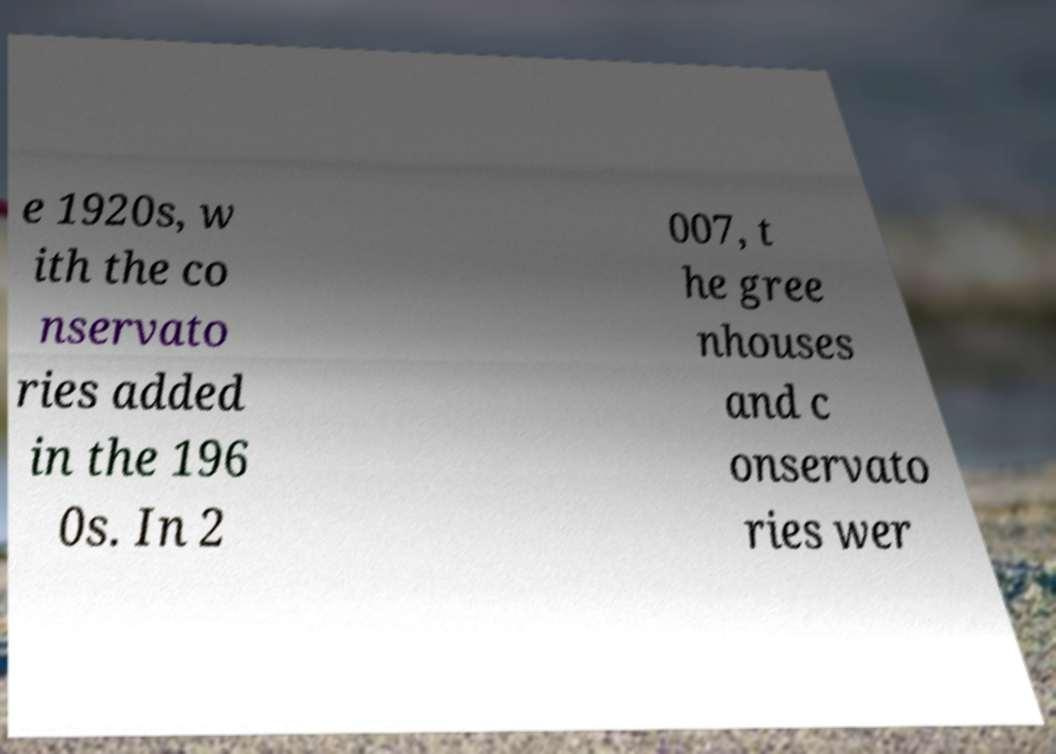I need the written content from this picture converted into text. Can you do that? e 1920s, w ith the co nservato ries added in the 196 0s. In 2 007, t he gree nhouses and c onservato ries wer 